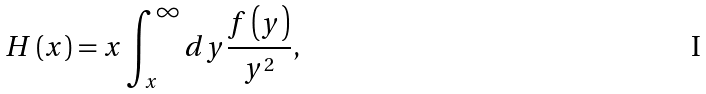Convert formula to latex. <formula><loc_0><loc_0><loc_500><loc_500>H \left ( x \right ) = x \int _ { x } ^ { \infty } d y \frac { f \left ( y \right ) } { y ^ { 2 } } ,</formula> 